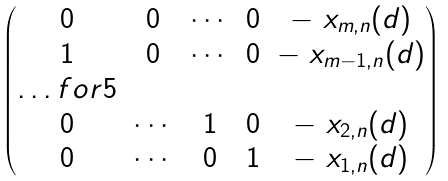<formula> <loc_0><loc_0><loc_500><loc_500>\begin{pmatrix} 0 & 0 & \cdots & 0 & - \ x _ { m , n } ( d ) \\ 1 & 0 & \cdots & 0 & - \ x _ { m - 1 , n } ( d ) \\ \hdots f o r { 5 } \\ 0 & \cdots & 1 & 0 & - \ x _ { 2 , n } ( d ) \\ 0 & \cdots & 0 & 1 & - \ x _ { 1 , n } ( d ) \end{pmatrix}</formula> 